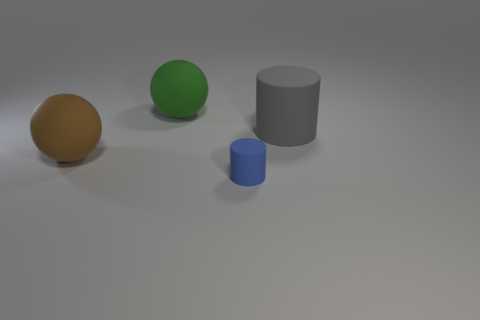What is the material of the large object right of the matte cylinder that is on the left side of the matte cylinder that is on the right side of the blue rubber thing?
Offer a very short reply. Rubber. Are there any small blue objects that have the same material as the big cylinder?
Provide a succinct answer. Yes. Does the blue thing have the same material as the large green sphere?
Your response must be concise. Yes. What number of cubes are either gray matte things or green objects?
Offer a terse response. 0. There is a cylinder that is the same material as the tiny thing; what color is it?
Offer a terse response. Gray. Are there fewer red cubes than big matte spheres?
Give a very brief answer. Yes. Is the shape of the tiny blue rubber object on the right side of the large brown ball the same as the rubber object to the right of the small matte cylinder?
Make the answer very short. Yes. How many things are tiny matte cylinders or small purple matte spheres?
Your answer should be compact. 1. There is another matte sphere that is the same size as the green sphere; what is its color?
Your response must be concise. Brown. What number of big matte objects are in front of the object that is to the right of the blue rubber object?
Make the answer very short. 1. 